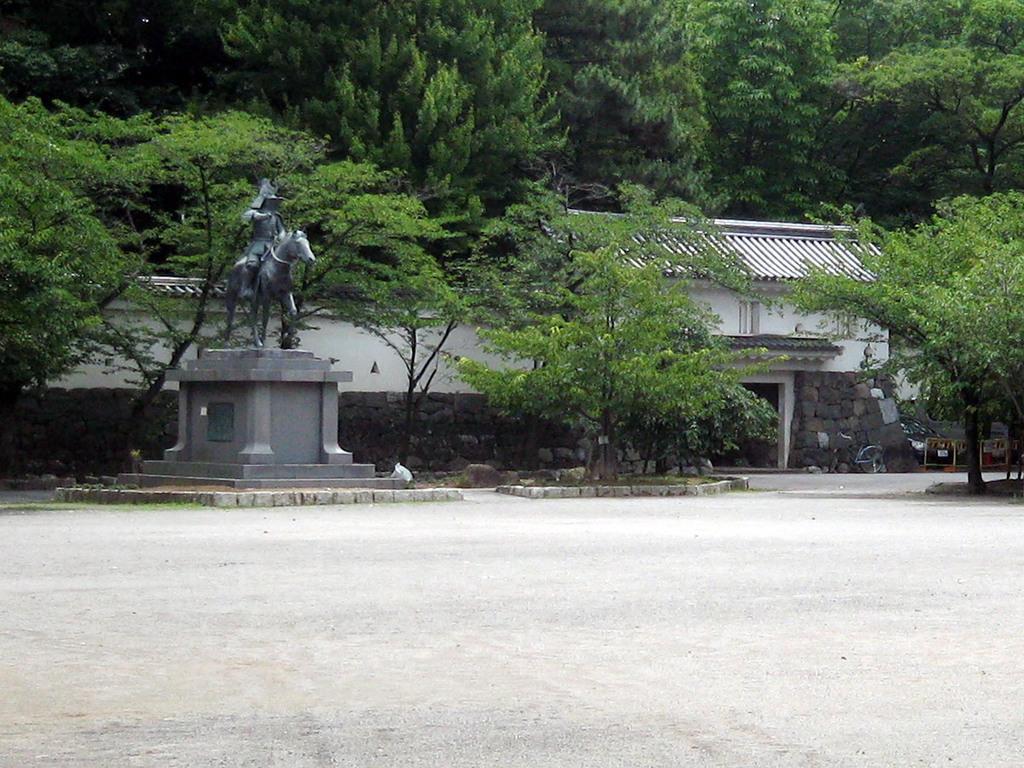Could you give a brief overview of what you see in this image? In this image there are trees and a wall, in front of the wall there is a statue. 